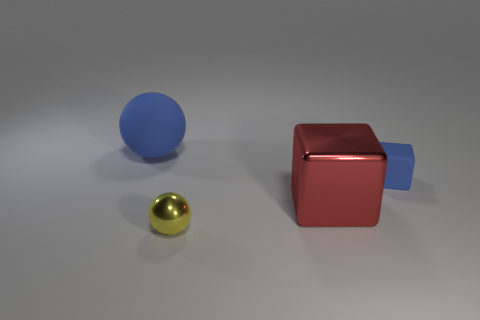Add 2 small blue matte things. How many objects exist? 6 Subtract all big gray spheres. Subtract all small rubber blocks. How many objects are left? 3 Add 1 big blue matte spheres. How many big blue matte spheres are left? 2 Add 1 brown rubber objects. How many brown rubber objects exist? 1 Subtract 0 purple spheres. How many objects are left? 4 